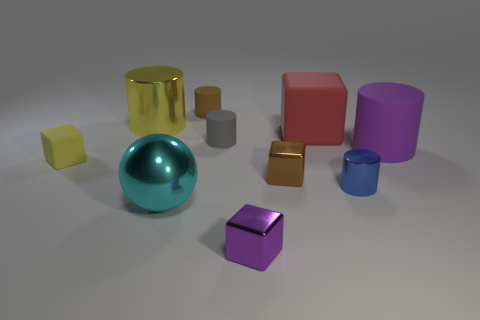How many other things are the same shape as the cyan metallic thing?
Ensure brevity in your answer.  0. What number of small shiny things are to the left of the small brown object behind the block to the left of the large metal cylinder?
Offer a very short reply. 0. There is a large metal object in front of the large yellow thing; what is its color?
Keep it short and to the point. Cyan. Is the color of the rubber thing to the left of the yellow shiny object the same as the sphere?
Keep it short and to the point. No. There is a purple metal thing that is the same shape as the small yellow rubber thing; what size is it?
Make the answer very short. Small. Are there any other things that are the same size as the brown metal object?
Your answer should be compact. Yes. There is a block to the left of the small brown thing that is left of the small block that is in front of the cyan thing; what is its material?
Provide a short and direct response. Rubber. Are there more cyan objects behind the yellow rubber cube than small gray objects left of the ball?
Your answer should be compact. No. Do the metal ball and the brown cylinder have the same size?
Make the answer very short. No. There is another rubber thing that is the same shape as the red matte object; what is its color?
Give a very brief answer. Yellow. 